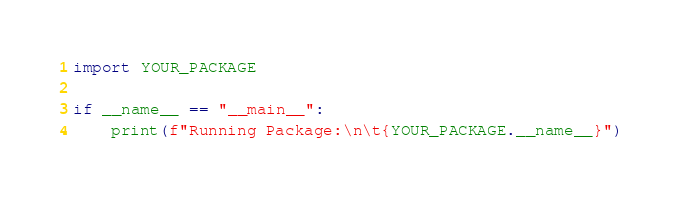Convert code to text. <code><loc_0><loc_0><loc_500><loc_500><_Python_>import YOUR_PACKAGE

if __name__ == "__main__":
    print(f"Running Package:\n\t{YOUR_PACKAGE.__name__}")
</code> 